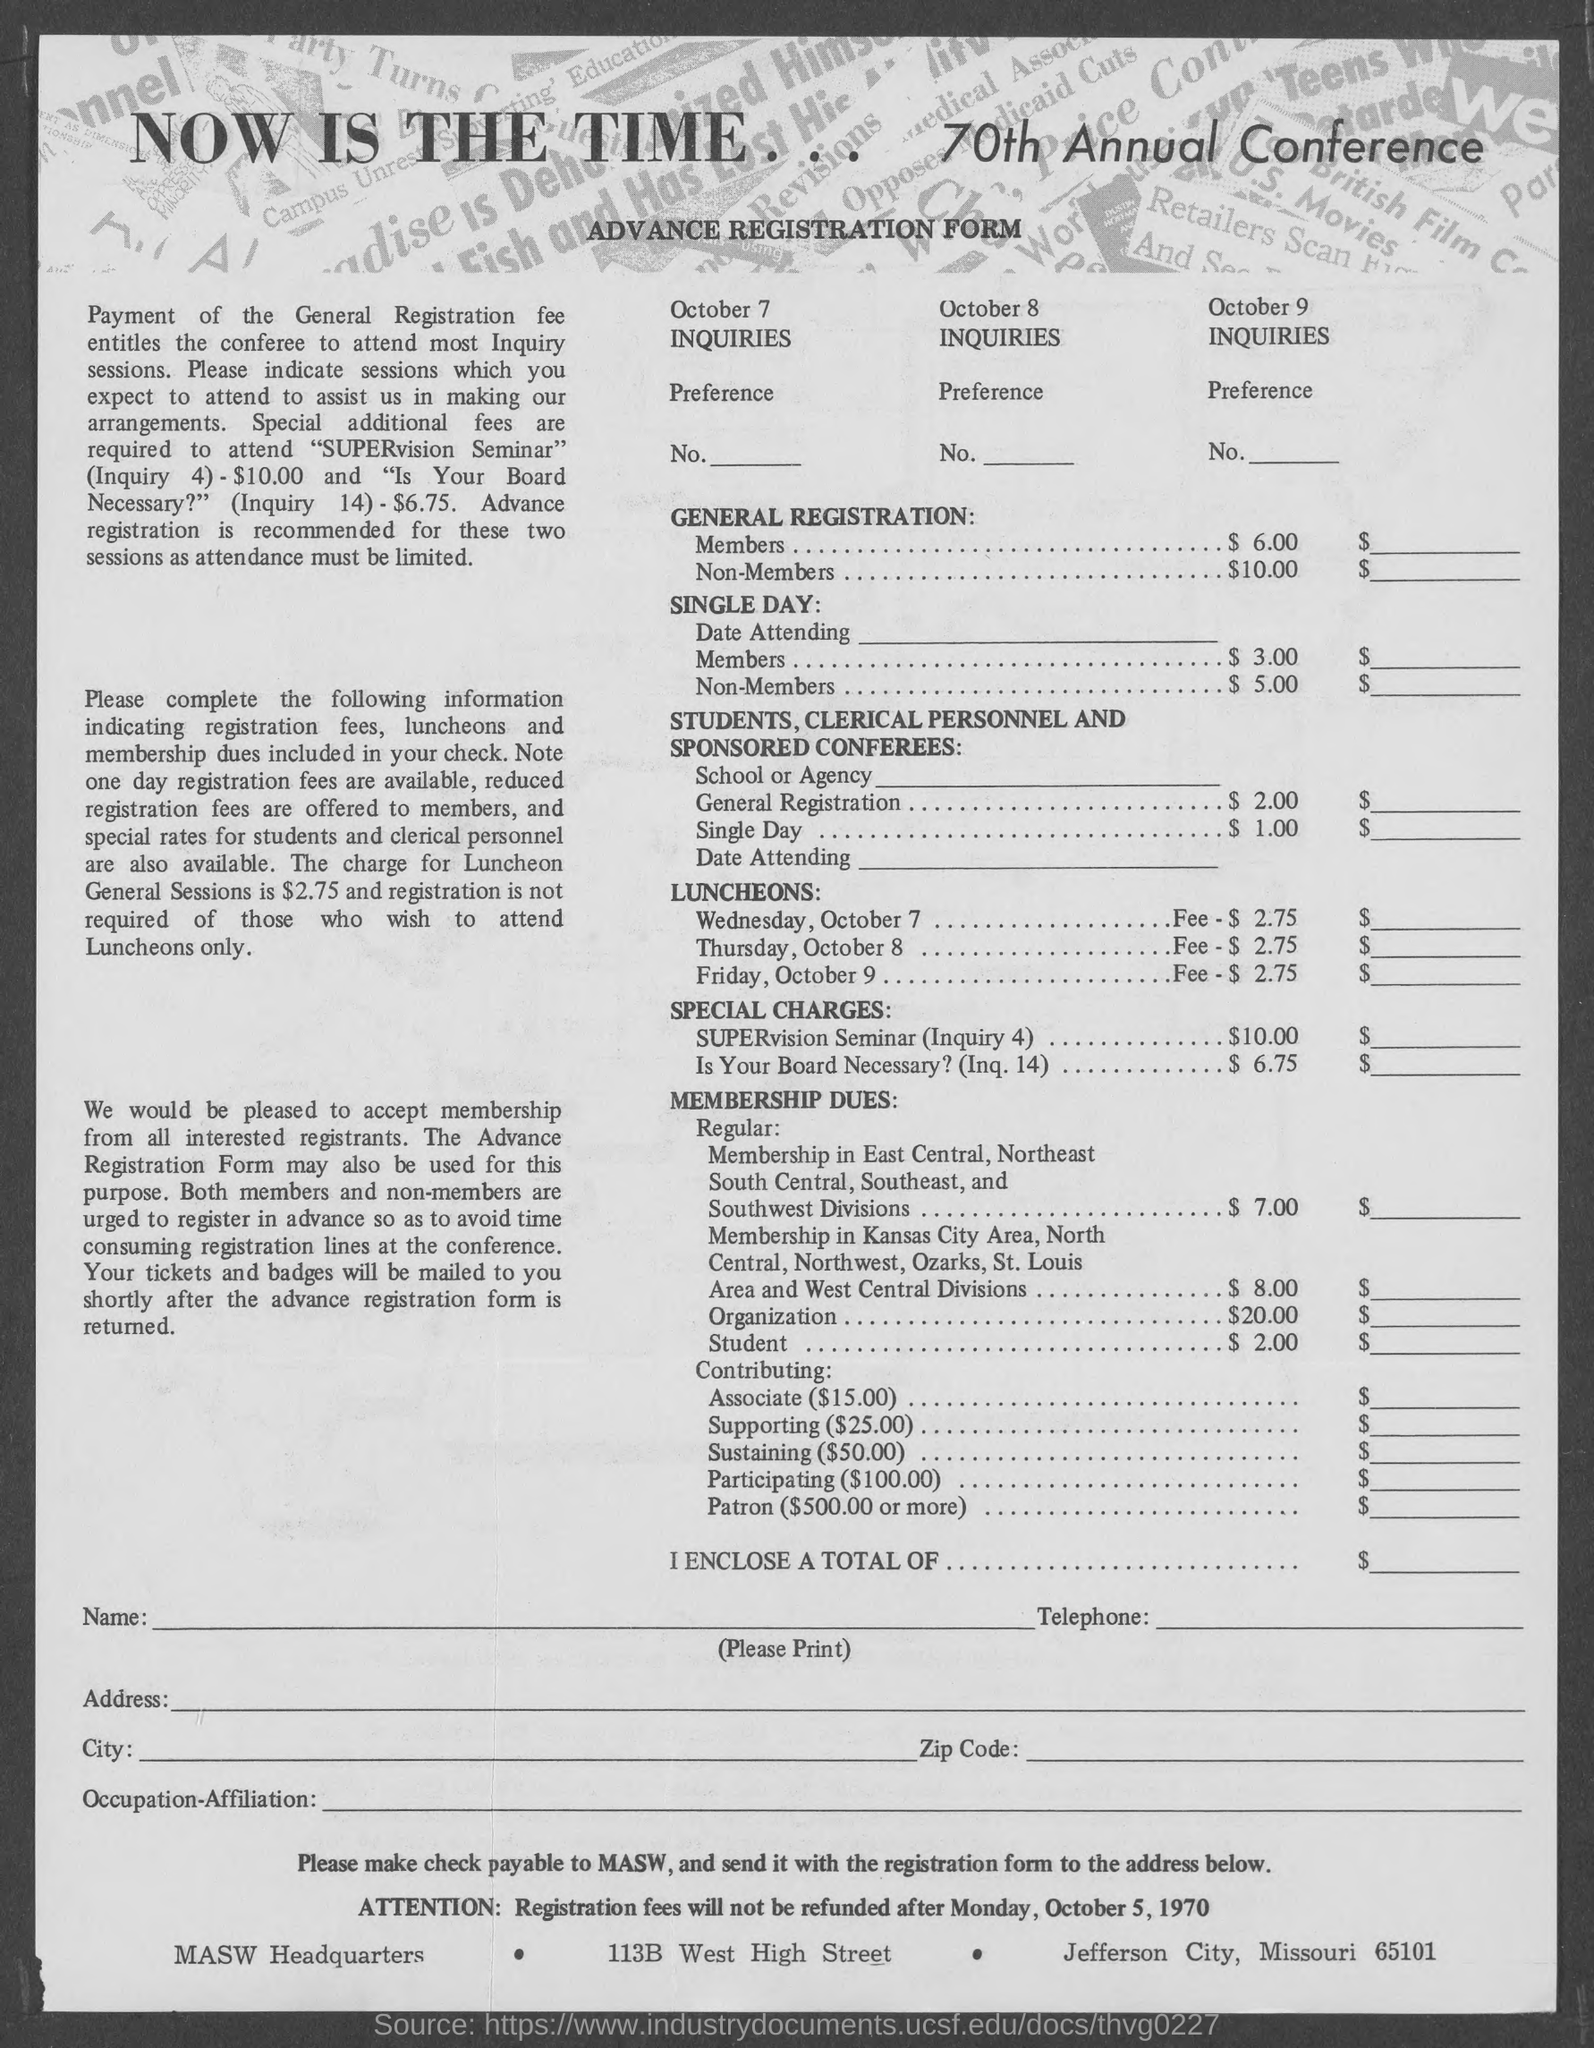Highlight a few significant elements in this photo. The charge for General Registration of Non-Members is $10.00. The name of the form is ADVANCE REGISTRATION FORM. The cost of general registration for members is $6.00. 